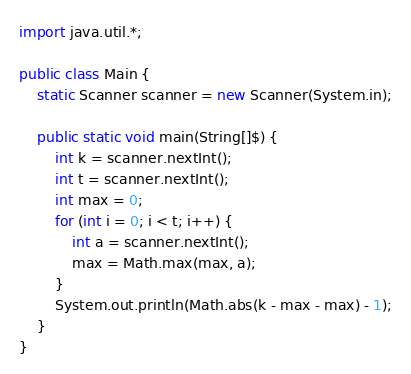Convert code to text. <code><loc_0><loc_0><loc_500><loc_500><_Java_>import java.util.*;

public class Main {
    static Scanner scanner = new Scanner(System.in);

    public static void main(String[]$) {
        int k = scanner.nextInt();
        int t = scanner.nextInt();
        int max = 0;
        for (int i = 0; i < t; i++) {
            int a = scanner.nextInt();
            max = Math.max(max, a);
        }
        System.out.println(Math.abs(k - max - max) - 1);
    }
}</code> 